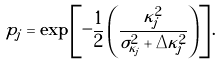<formula> <loc_0><loc_0><loc_500><loc_500>p _ { j } = \exp \left [ - \frac { 1 } { 2 } \left ( \frac { \kappa _ { j } ^ { 2 } } { \sigma _ { \kappa _ { j } } ^ { 2 } + \Delta \kappa _ { j } ^ { 2 } } \right ) \right ] .</formula> 